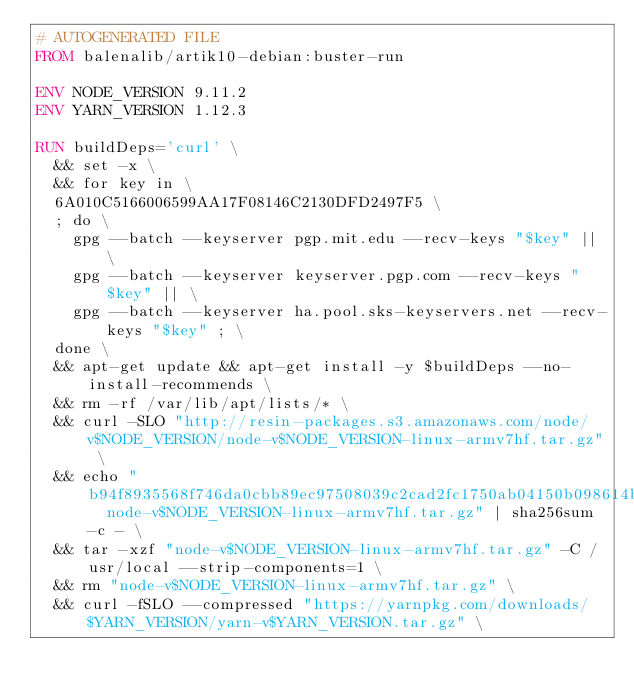<code> <loc_0><loc_0><loc_500><loc_500><_Dockerfile_># AUTOGENERATED FILE
FROM balenalib/artik10-debian:buster-run

ENV NODE_VERSION 9.11.2
ENV YARN_VERSION 1.12.3

RUN buildDeps='curl' \
	&& set -x \
	&& for key in \
	6A010C5166006599AA17F08146C2130DFD2497F5 \
	; do \
		gpg --batch --keyserver pgp.mit.edu --recv-keys "$key" || \
		gpg --batch --keyserver keyserver.pgp.com --recv-keys "$key" || \
		gpg --batch --keyserver ha.pool.sks-keyservers.net --recv-keys "$key" ; \
	done \
	&& apt-get update && apt-get install -y $buildDeps --no-install-recommends \
	&& rm -rf /var/lib/apt/lists/* \
	&& curl -SLO "http://resin-packages.s3.amazonaws.com/node/v$NODE_VERSION/node-v$NODE_VERSION-linux-armv7hf.tar.gz" \
	&& echo "b94f8935568f746da0cbb89ec97508039c2cad2fc1750ab04150b098614b9241  node-v$NODE_VERSION-linux-armv7hf.tar.gz" | sha256sum -c - \
	&& tar -xzf "node-v$NODE_VERSION-linux-armv7hf.tar.gz" -C /usr/local --strip-components=1 \
	&& rm "node-v$NODE_VERSION-linux-armv7hf.tar.gz" \
	&& curl -fSLO --compressed "https://yarnpkg.com/downloads/$YARN_VERSION/yarn-v$YARN_VERSION.tar.gz" \</code> 